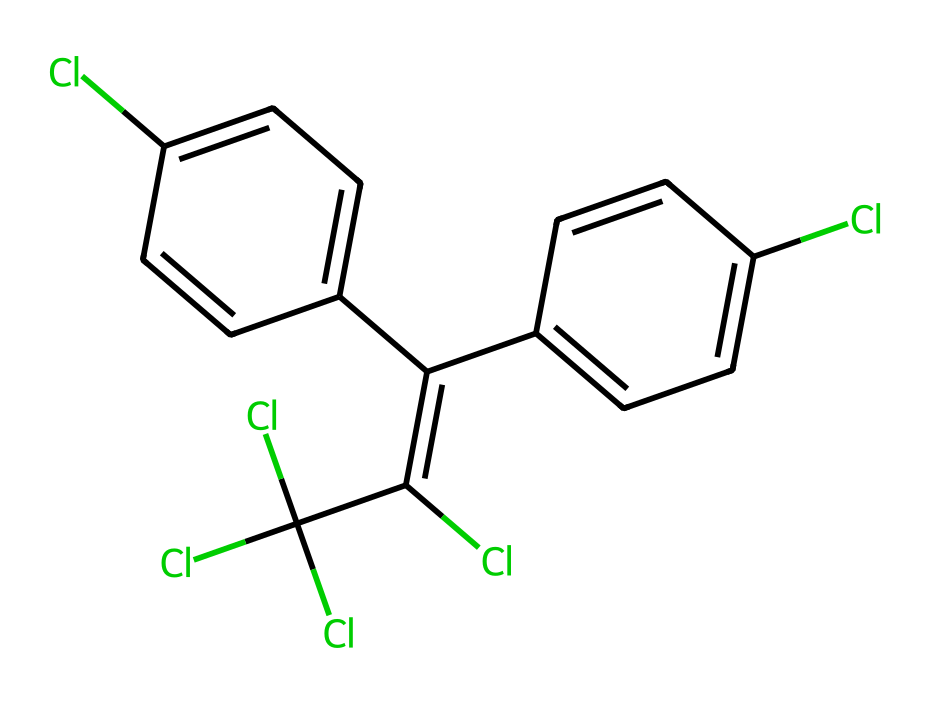what is the name of this chemical? The chemical is known as DDT, which stands for dichloro-diphenyl-trichloroethane. This name is derived from its molecular structure, which includes two phenyl rings and multiple chlorine atoms.
Answer: DDT how many chlorine atoms are present in the structure? By analyzing the SMILES representation, we count the occurrences of 'Cl', which appears four times, indicating four chlorine atoms are present in the structure.
Answer: four how many rings are present in the molecular structure? The SMILES indicates two distinct phenyl rings in the structure, distinguished by the 'C1' and 'C2' designations, which connect cyclic components. Therefore, the count totals to two rings.
Answer: two what is the primary function of DDT as a pesticide? DDT is primarily used for its insecticidal properties to kill a variety of insects by disrupting their nervous systems. This function is pivotal in agricultural practices and vector control for diseases like malaria.
Answer: insecticide how does the presence of chlorine affect DDT's toxicity? The chlorine atoms in DDT contribute to its lipophilicity and stability, leading to accumulation in the fatty tissues of organisms, which raises toxicity levels and enhances environmental persistence, making it hazardous.
Answer: increases toxicity what might be a reason for the ban on DDT? Due to its environmental persistence and bioaccumulation in the food chain, DDT has been banned in many places because it poses significant risks to human health and wildlife.
Answer: environmental hazards 